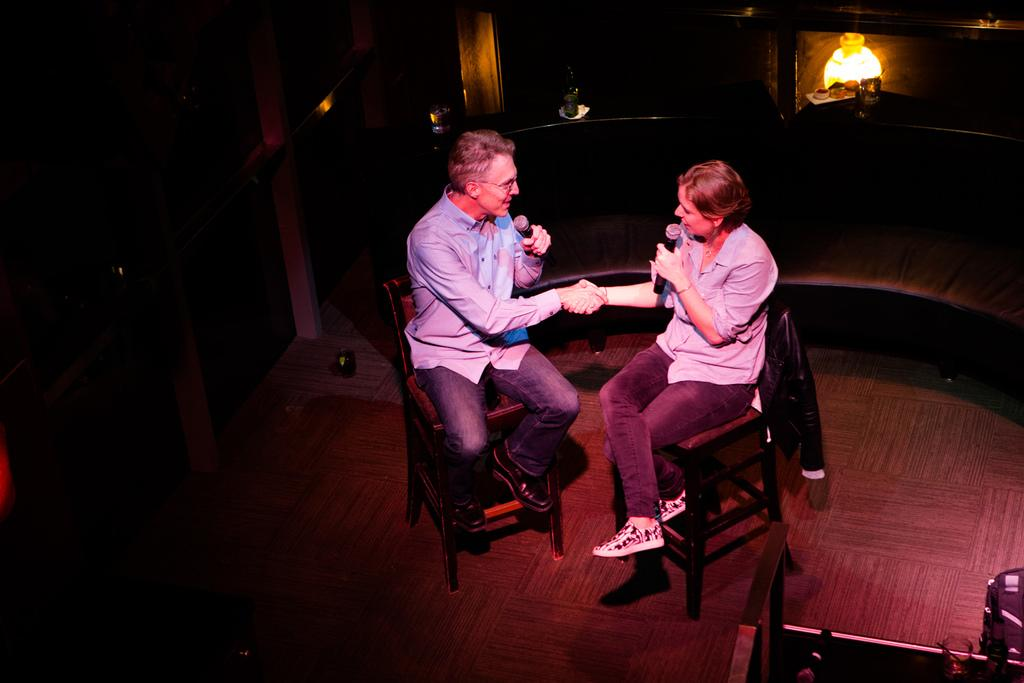Who is present in the image? There is a man and a woman in the image. What are the man and woman doing in the image? The man and woman are sitting on chairs and holding microphones. Can you describe their hand positions in the image? The man and woman have their hands visible, as they are holding microphones. What type of decision can be seen on the coach in the image? There is no coach or decision present in the image. What sound does the alarm make in the image? There is no alarm present in the image. 